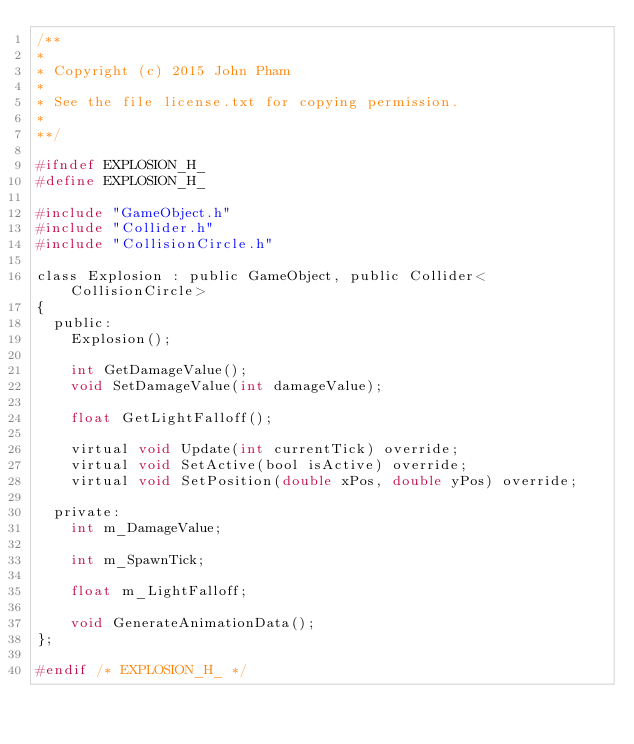Convert code to text. <code><loc_0><loc_0><loc_500><loc_500><_C_>/**
*
* Copyright (c) 2015 John Pham
*
* See the file license.txt for copying permission.
*
**/

#ifndef EXPLOSION_H_
#define EXPLOSION_H_

#include "GameObject.h"
#include "Collider.h"
#include "CollisionCircle.h"

class Explosion : public GameObject, public Collider<CollisionCircle> 
{
	public:
		Explosion();

		int GetDamageValue();
		void SetDamageValue(int damageValue);

		float GetLightFalloff();

		virtual void Update(int currentTick) override;
		virtual void SetActive(bool isActive) override;
		virtual void SetPosition(double xPos, double yPos) override;

	private:
		int m_DamageValue;

		int m_SpawnTick;

		float m_LightFalloff;

		void GenerateAnimationData();
};

#endif /* EXPLOSION_H_ */</code> 